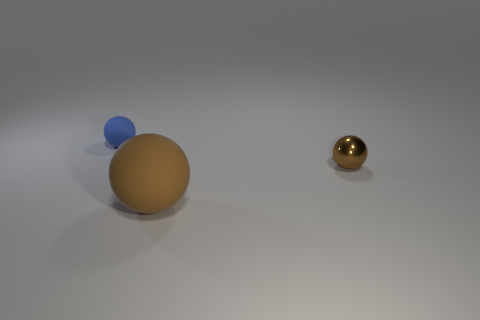Subtract all rubber spheres. How many spheres are left? 1 Add 1 large rubber cubes. How many objects exist? 4 Subtract all yellow cubes. How many brown balls are left? 2 Subtract all brown balls. How many balls are left? 1 Subtract 1 spheres. How many spheres are left? 2 Subtract 0 red blocks. How many objects are left? 3 Subtract all red balls. Subtract all brown blocks. How many balls are left? 3 Subtract all brown matte objects. Subtract all tiny blue balls. How many objects are left? 1 Add 2 brown balls. How many brown balls are left? 4 Add 2 tiny red cubes. How many tiny red cubes exist? 2 